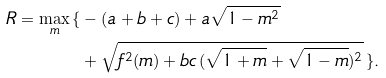<formula> <loc_0><loc_0><loc_500><loc_500>R = \max _ { m } \, \{ & - ( a + b + c ) + a \sqrt { 1 - m ^ { 2 } } \\ & + \sqrt { f ^ { 2 } ( m ) + b c \, ( \sqrt { 1 + m } + \sqrt { 1 - m } ) ^ { 2 } } \, \} .</formula> 